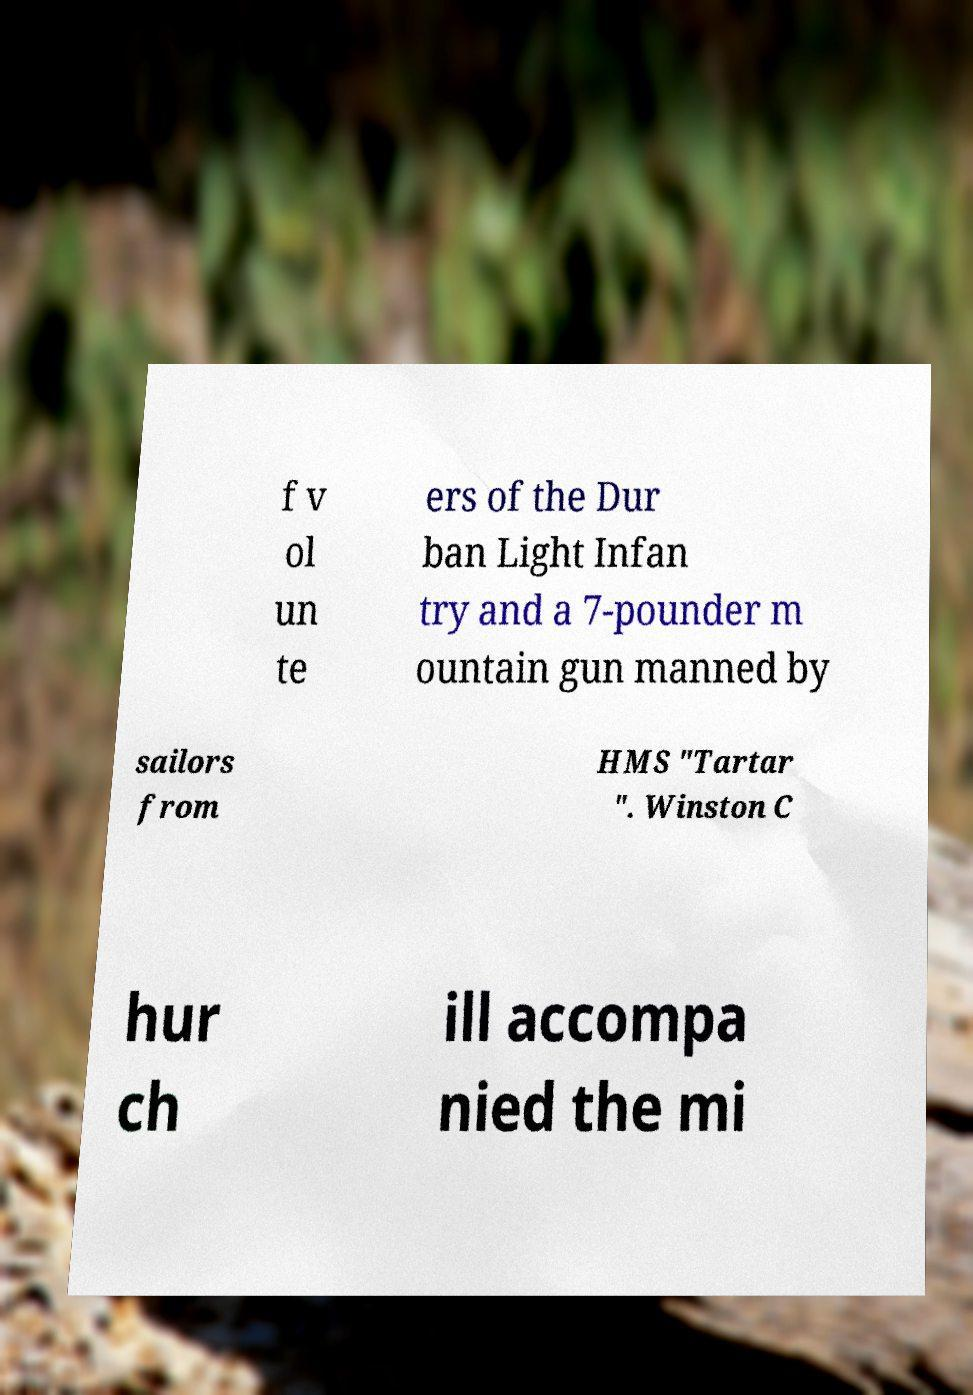Can you read and provide the text displayed in the image?This photo seems to have some interesting text. Can you extract and type it out for me? f v ol un te ers of the Dur ban Light Infan try and a 7-pounder m ountain gun manned by sailors from HMS "Tartar ". Winston C hur ch ill accompa nied the mi 